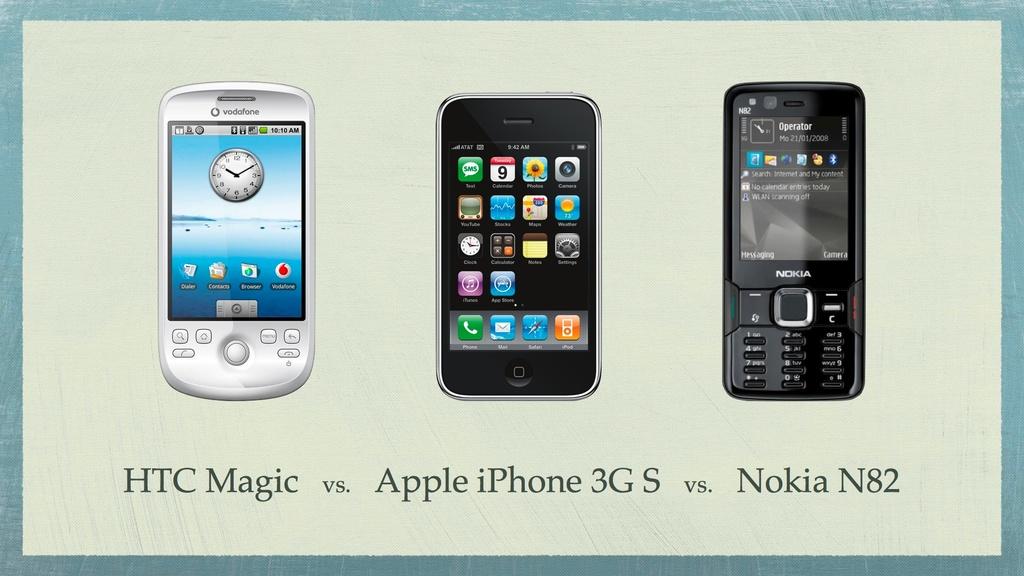What kind of phone is on the right?
Your answer should be compact. Nokia n82. What brand of phone on the right?
Provide a short and direct response. Nokia. 